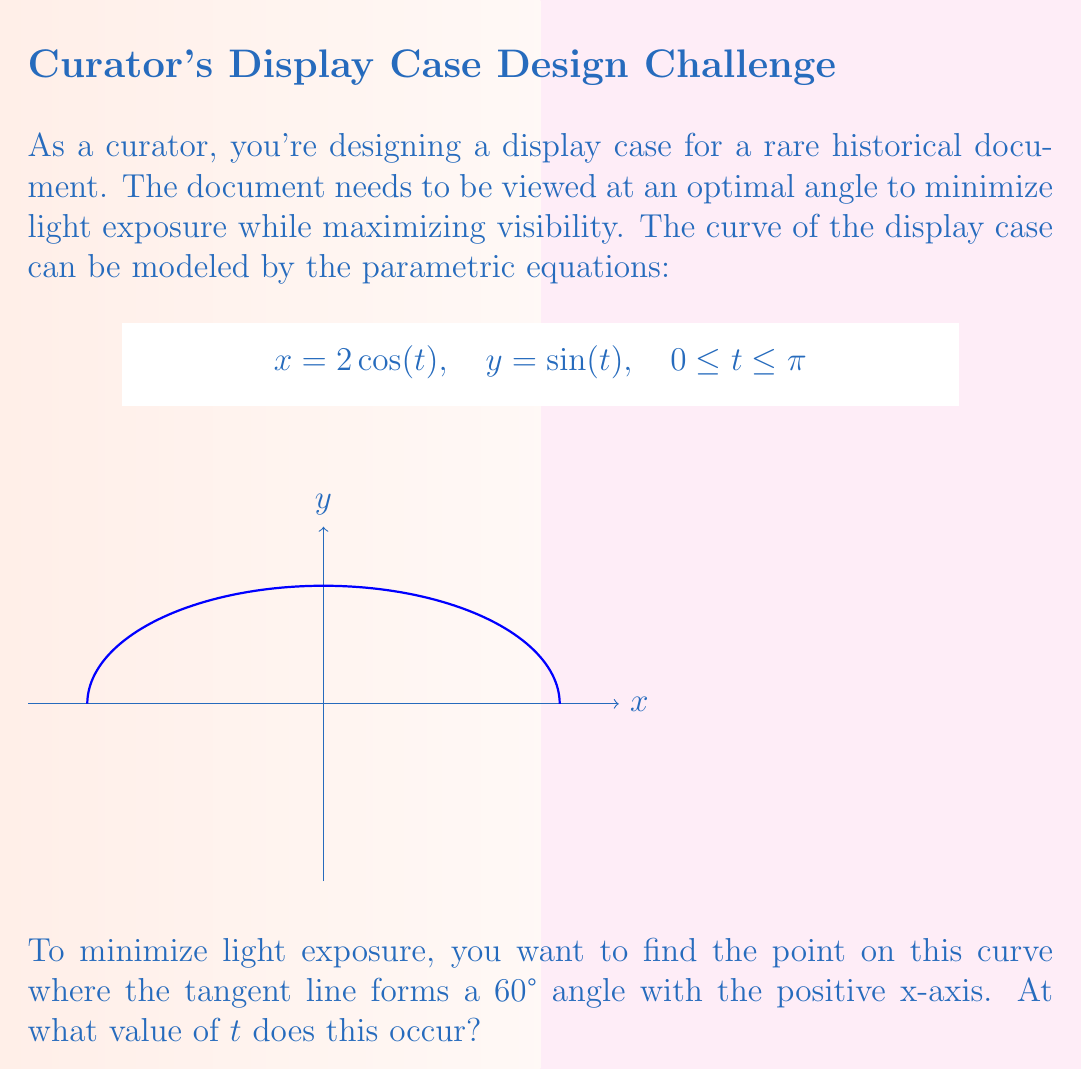Show me your answer to this math problem. Let's approach this step-by-step:

1) The tangent vector to the curve at any point is given by:
   $$\vec{v} = \left(\frac{dx}{dt}, \frac{dy}{dt}\right) = (-2\sin(t), \cos(t))$$

2) The angle $\theta$ between this vector and the positive x-axis is given by:
   $$\tan(\theta) = \frac{dy/dt}{dx/dt} = -\frac{\cos(t)}{2\sin(t)}$$

3) We want this angle to be 60°, so:
   $$\tan(60°) = -\frac{\cos(t)}{2\sin(t)}$$

4) We know that $\tan(60°) = \sqrt{3}$, so:
   $$\sqrt{3} = -\frac{\cos(t)}{2\sin(t)}$$

5) Cross-multiplying:
   $$2\sqrt{3}\sin(t) = -\cos(t)$$

6) Dividing both sides by $\cos(t)$ (assuming $\cos(t) \neq 0$):
   $$-2\sqrt{3}\tan(t) = 1$$

7) Solving for $t$:
   $$\tan(t) = -\frac{1}{2\sqrt{3}}$$
   $$t = \arctan\left(-\frac{1}{2\sqrt{3}}\right)$$

8) This gives us $t \approx 2.356$ radians or $135°$.

9) We need to check if this solution is within our domain $0 \leq t \leq \pi$. It is, so this is our final answer.
Answer: $t = \arctan\left(-\frac{1}{2\sqrt{3}}\right)$ radians 